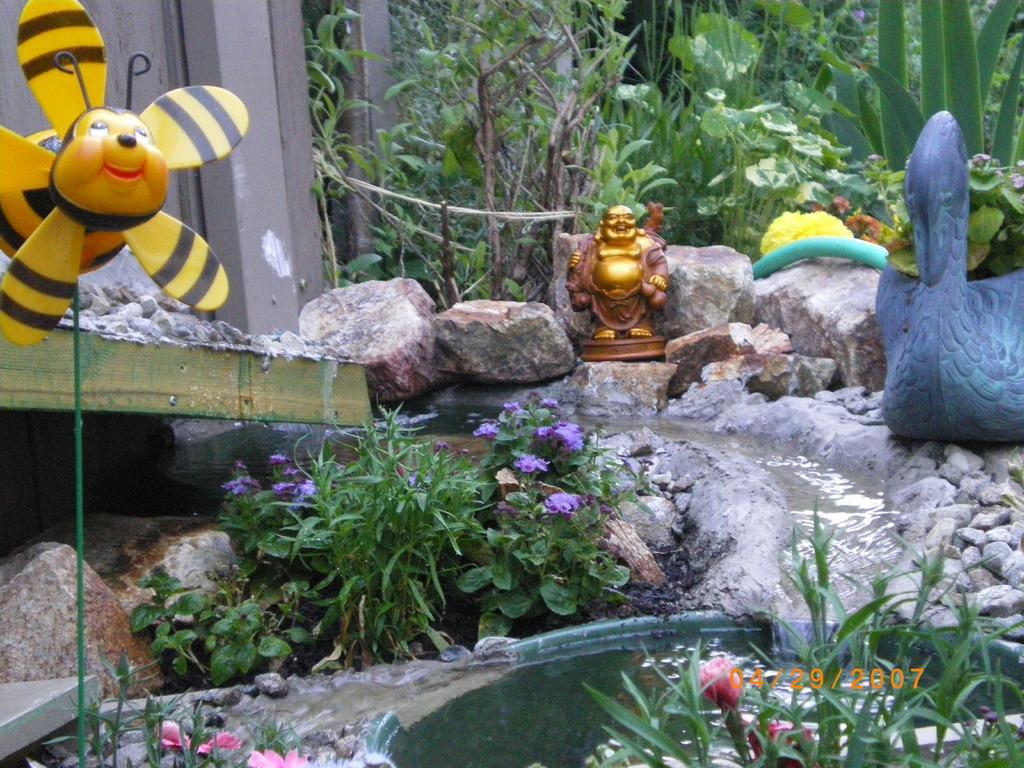Can you describe this image briefly? Here i can see some water. Around this there are some plants and rocks and also I can see few toys. 